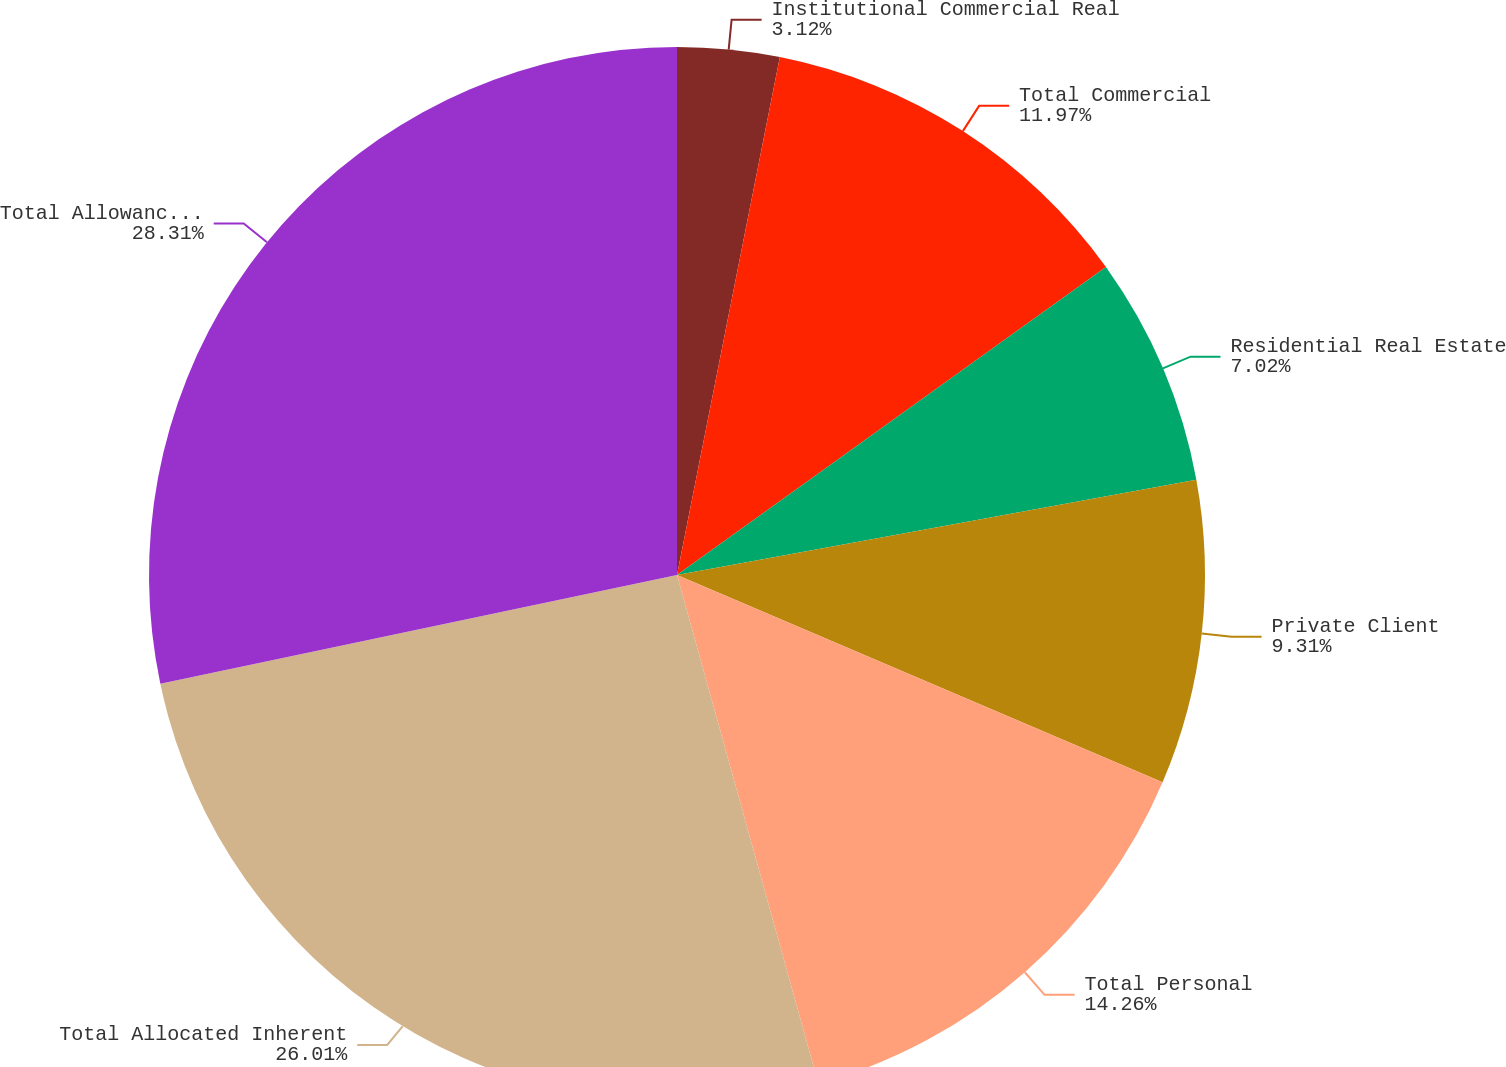Convert chart. <chart><loc_0><loc_0><loc_500><loc_500><pie_chart><fcel>Institutional Commercial Real<fcel>Total Commercial<fcel>Residential Real Estate<fcel>Private Client<fcel>Total Personal<fcel>Total Allocated Inherent<fcel>Total Allowance for Credit<nl><fcel>3.12%<fcel>11.97%<fcel>7.02%<fcel>9.31%<fcel>14.26%<fcel>26.01%<fcel>28.3%<nl></chart> 